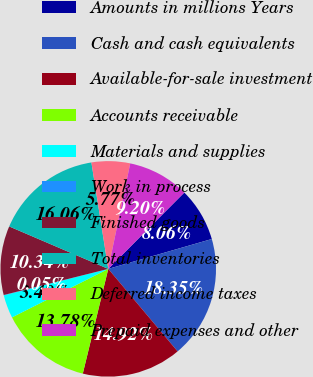Convert chart to OTSL. <chart><loc_0><loc_0><loc_500><loc_500><pie_chart><fcel>Amounts in millions Years<fcel>Cash and cash equivalents<fcel>Available-for-sale investment<fcel>Accounts receivable<fcel>Materials and supplies<fcel>Work in process<fcel>Finished goods<fcel>Total inventories<fcel>Deferred income taxes<fcel>Prepaid expenses and other<nl><fcel>8.06%<fcel>18.35%<fcel>14.92%<fcel>13.78%<fcel>3.48%<fcel>0.05%<fcel>10.34%<fcel>16.06%<fcel>5.77%<fcel>9.2%<nl></chart> 